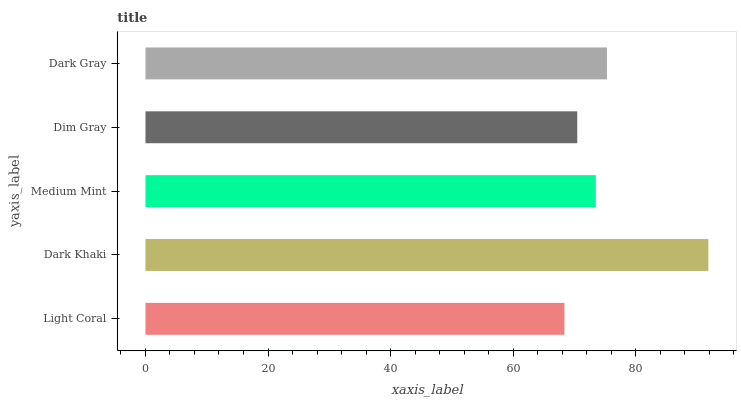Is Light Coral the minimum?
Answer yes or no. Yes. Is Dark Khaki the maximum?
Answer yes or no. Yes. Is Medium Mint the minimum?
Answer yes or no. No. Is Medium Mint the maximum?
Answer yes or no. No. Is Dark Khaki greater than Medium Mint?
Answer yes or no. Yes. Is Medium Mint less than Dark Khaki?
Answer yes or no. Yes. Is Medium Mint greater than Dark Khaki?
Answer yes or no. No. Is Dark Khaki less than Medium Mint?
Answer yes or no. No. Is Medium Mint the high median?
Answer yes or no. Yes. Is Medium Mint the low median?
Answer yes or no. Yes. Is Dark Khaki the high median?
Answer yes or no. No. Is Dark Gray the low median?
Answer yes or no. No. 